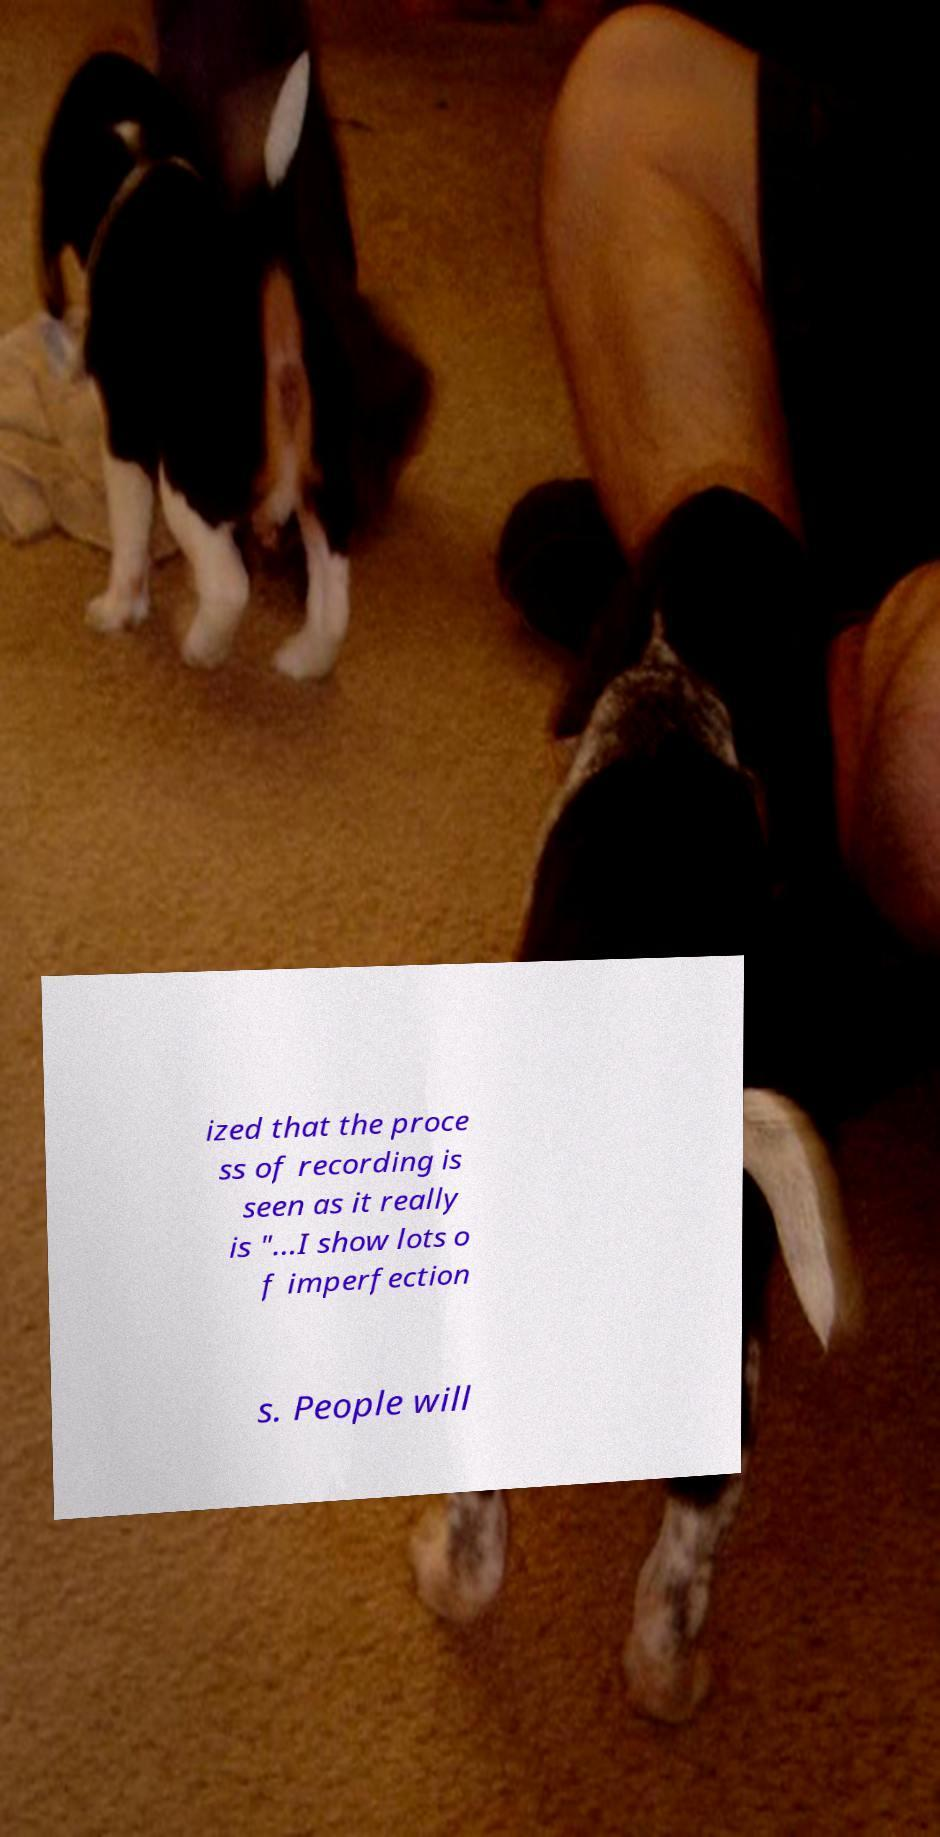Could you extract and type out the text from this image? ized that the proce ss of recording is seen as it really is "...I show lots o f imperfection s. People will 